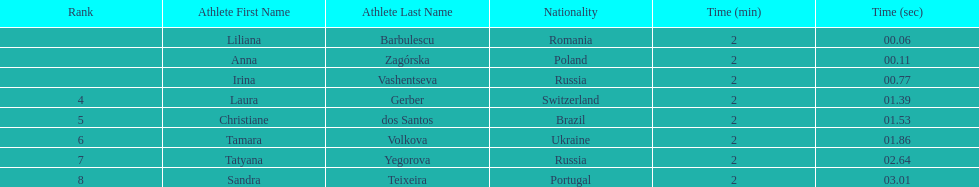What is the number of russian participants in this set of semifinals? 2. 